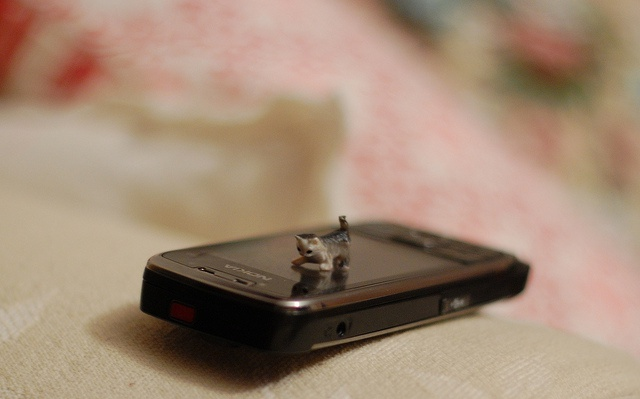Describe the objects in this image and their specific colors. I can see couch in tan, black, and gray tones, cell phone in maroon, black, and gray tones, and cat in maroon, gray, and black tones in this image. 